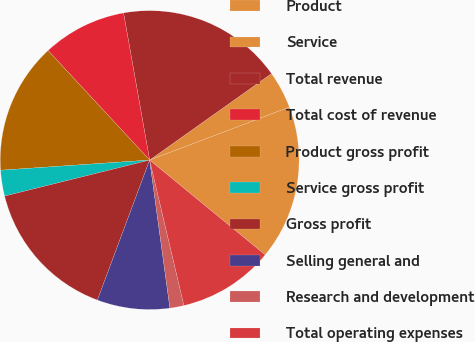Convert chart to OTSL. <chart><loc_0><loc_0><loc_500><loc_500><pie_chart><fcel>Product<fcel>Service<fcel>Total revenue<fcel>Total cost of revenue<fcel>Product gross profit<fcel>Service gross profit<fcel>Gross profit<fcel>Selling general and<fcel>Research and development<fcel>Total operating expenses<nl><fcel>16.71%<fcel>4.05%<fcel>17.97%<fcel>9.11%<fcel>14.18%<fcel>2.79%<fcel>15.44%<fcel>7.85%<fcel>1.52%<fcel>10.38%<nl></chart> 